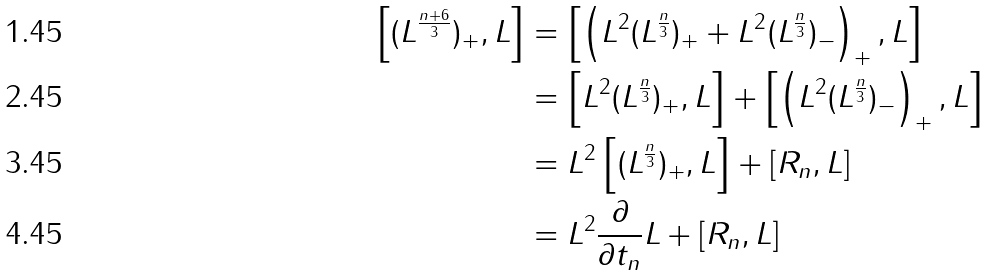Convert formula to latex. <formula><loc_0><loc_0><loc_500><loc_500>\left [ ( L ^ { \frac { n + 6 } { 3 } } ) _ { + } , L \right ] & = \left [ \left ( L ^ { 2 } ( L ^ { \frac { n } { 3 } } ) _ { + } + L ^ { 2 } ( L ^ { \frac { n } { 3 } } ) _ { - } \right ) _ { + } , L \right ] \\ & = \left [ L ^ { 2 } ( L ^ { \frac { n } { 3 } } ) _ { + } , L \right ] + \left [ \left ( L ^ { 2 } ( L ^ { \frac { n } { 3 } } ) _ { - } \right ) _ { + } , L \right ] \\ & = L ^ { 2 } \left [ ( L ^ { \frac { n } { 3 } } ) _ { + } , L \right ] + [ R _ { n } , L ] \\ & = L ^ { 2 } \frac { \partial } { \partial t _ { n } } L + [ R _ { n } , L ]</formula> 